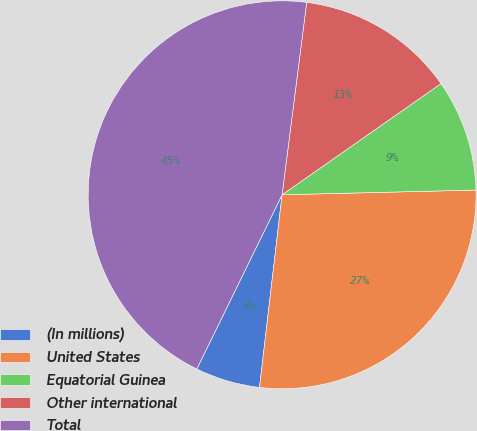Convert chart to OTSL. <chart><loc_0><loc_0><loc_500><loc_500><pie_chart><fcel>(In millions)<fcel>United States<fcel>Equatorial Guinea<fcel>Other international<fcel>Total<nl><fcel>5.39%<fcel>27.25%<fcel>9.33%<fcel>13.26%<fcel>44.78%<nl></chart> 